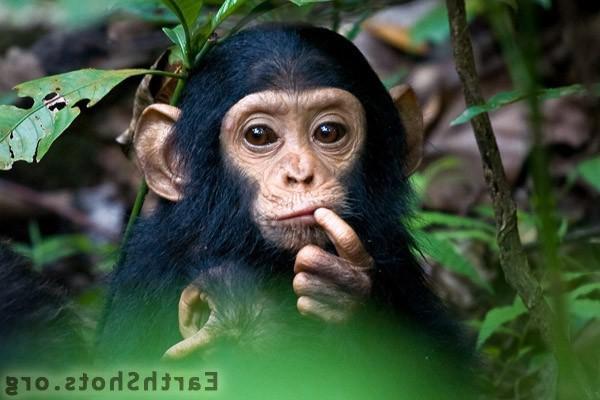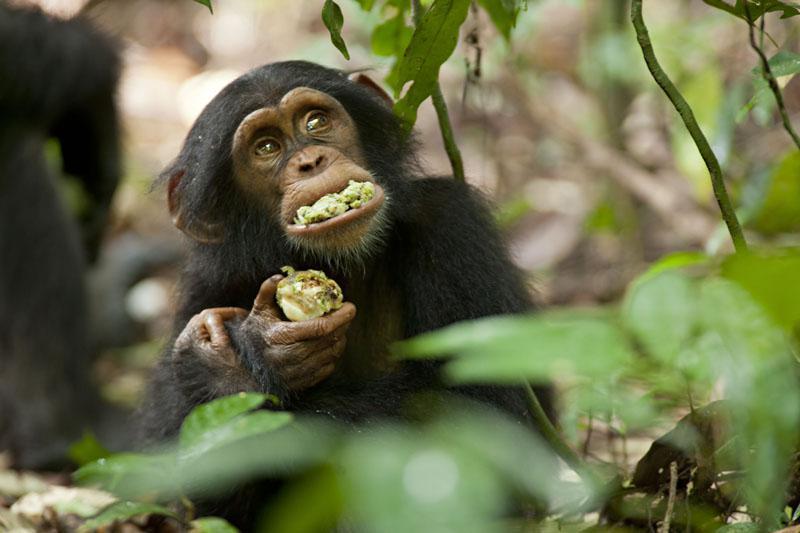The first image is the image on the left, the second image is the image on the right. Analyze the images presented: Is the assertion "One of the images contains a monkey that is holding its finger on its mouth." valid? Answer yes or no. Yes. 